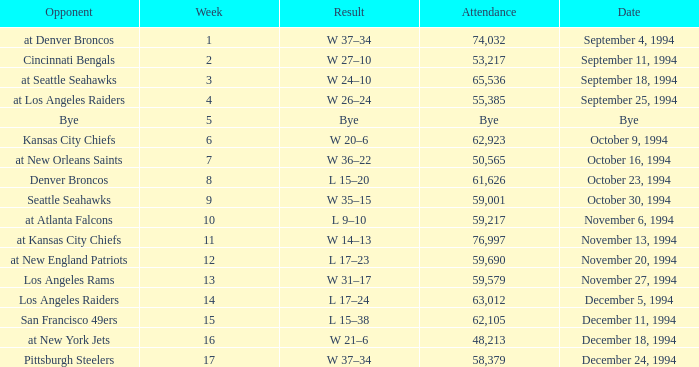On November 20, 1994, what was the result of the game? L 17–23. 